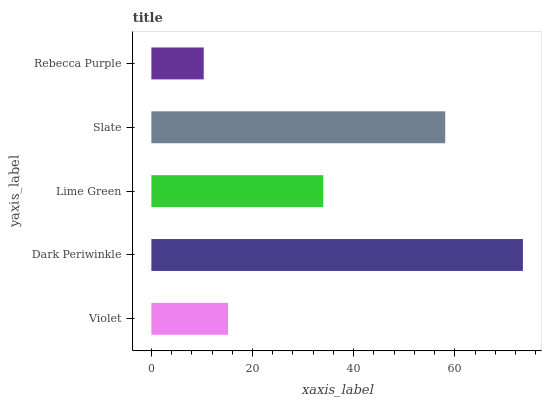Is Rebecca Purple the minimum?
Answer yes or no. Yes. Is Dark Periwinkle the maximum?
Answer yes or no. Yes. Is Lime Green the minimum?
Answer yes or no. No. Is Lime Green the maximum?
Answer yes or no. No. Is Dark Periwinkle greater than Lime Green?
Answer yes or no. Yes. Is Lime Green less than Dark Periwinkle?
Answer yes or no. Yes. Is Lime Green greater than Dark Periwinkle?
Answer yes or no. No. Is Dark Periwinkle less than Lime Green?
Answer yes or no. No. Is Lime Green the high median?
Answer yes or no. Yes. Is Lime Green the low median?
Answer yes or no. Yes. Is Violet the high median?
Answer yes or no. No. Is Violet the low median?
Answer yes or no. No. 